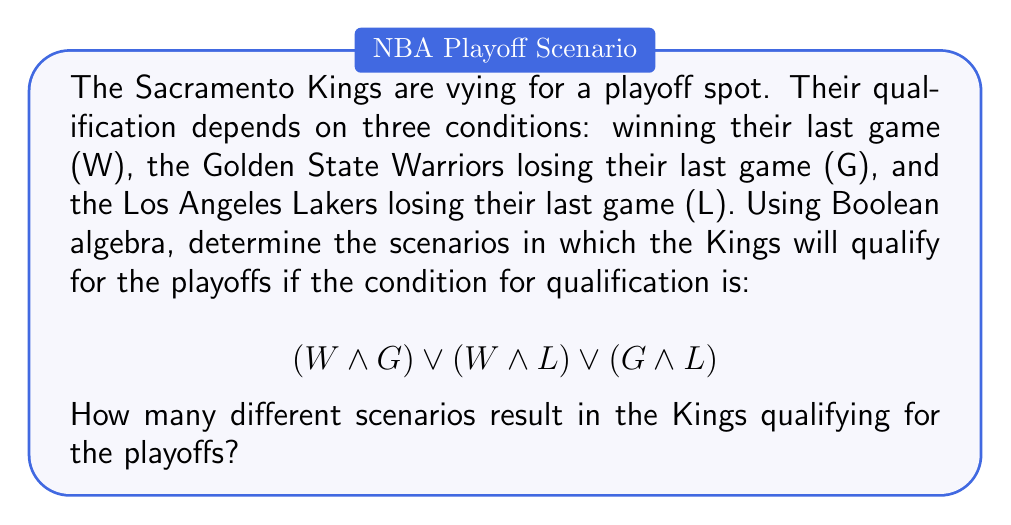Solve this math problem. Let's approach this step-by-step:

1) We have three variables: W, G, and L. Each can be either true (1) or false (0).

2) The qualification condition is:
   $$(W \land G) \lor (W \land L) \lor (G \land L)$$

3) To find all scenarios where the Kings qualify, we need to evaluate this expression for all possible combinations of W, G, and L.

4) There are $2^3 = 8$ possible combinations:

   W G L | Result
   ------+-------
   0 0 0 | 0
   0 0 1 | 0
   0 1 0 | 0
   0 1 1 | 1
   1 0 0 | 0
   1 0 1 | 1
   1 1 0 | 1
   1 1 1 | 1

5) Let's evaluate each case:
   - (0,0,0): $(0 \land 0) \lor (0 \land 0) \lor (0 \land 0) = 0 \lor 0 \lor 0 = 0$
   - (0,0,1): $(0 \land 0) \lor (0 \land 1) \lor (0 \land 1) = 0 \lor 0 \lor 0 = 0$
   - (0,1,0): $(0 \land 1) \lor (0 \land 0) \lor (1 \land 0) = 0 \lor 0 \lor 0 = 0$
   - (0,1,1): $(0 \land 1) \lor (0 \land 1) \lor (1 \land 1) = 0 \lor 0 \lor 1 = 1$
   - (1,0,0): $(1 \land 0) \lor (1 \land 0) \lor (0 \land 0) = 0 \lor 0 \lor 0 = 0$
   - (1,0,1): $(1 \land 0) \lor (1 \land 1) \lor (0 \land 1) = 0 \lor 1 \lor 0 = 1$
   - (1,1,0): $(1 \land 1) \lor (1 \land 0) \lor (1 \land 0) = 1 \lor 0 \lor 0 = 1$
   - (1,1,1): $(1 \land 1) \lor (1 \land 1) \lor (1 \land 1) = 1 \lor 1 \lor 1 = 1$

6) Counting the number of scenarios where the result is 1, we get 4 scenarios.
Answer: 4 